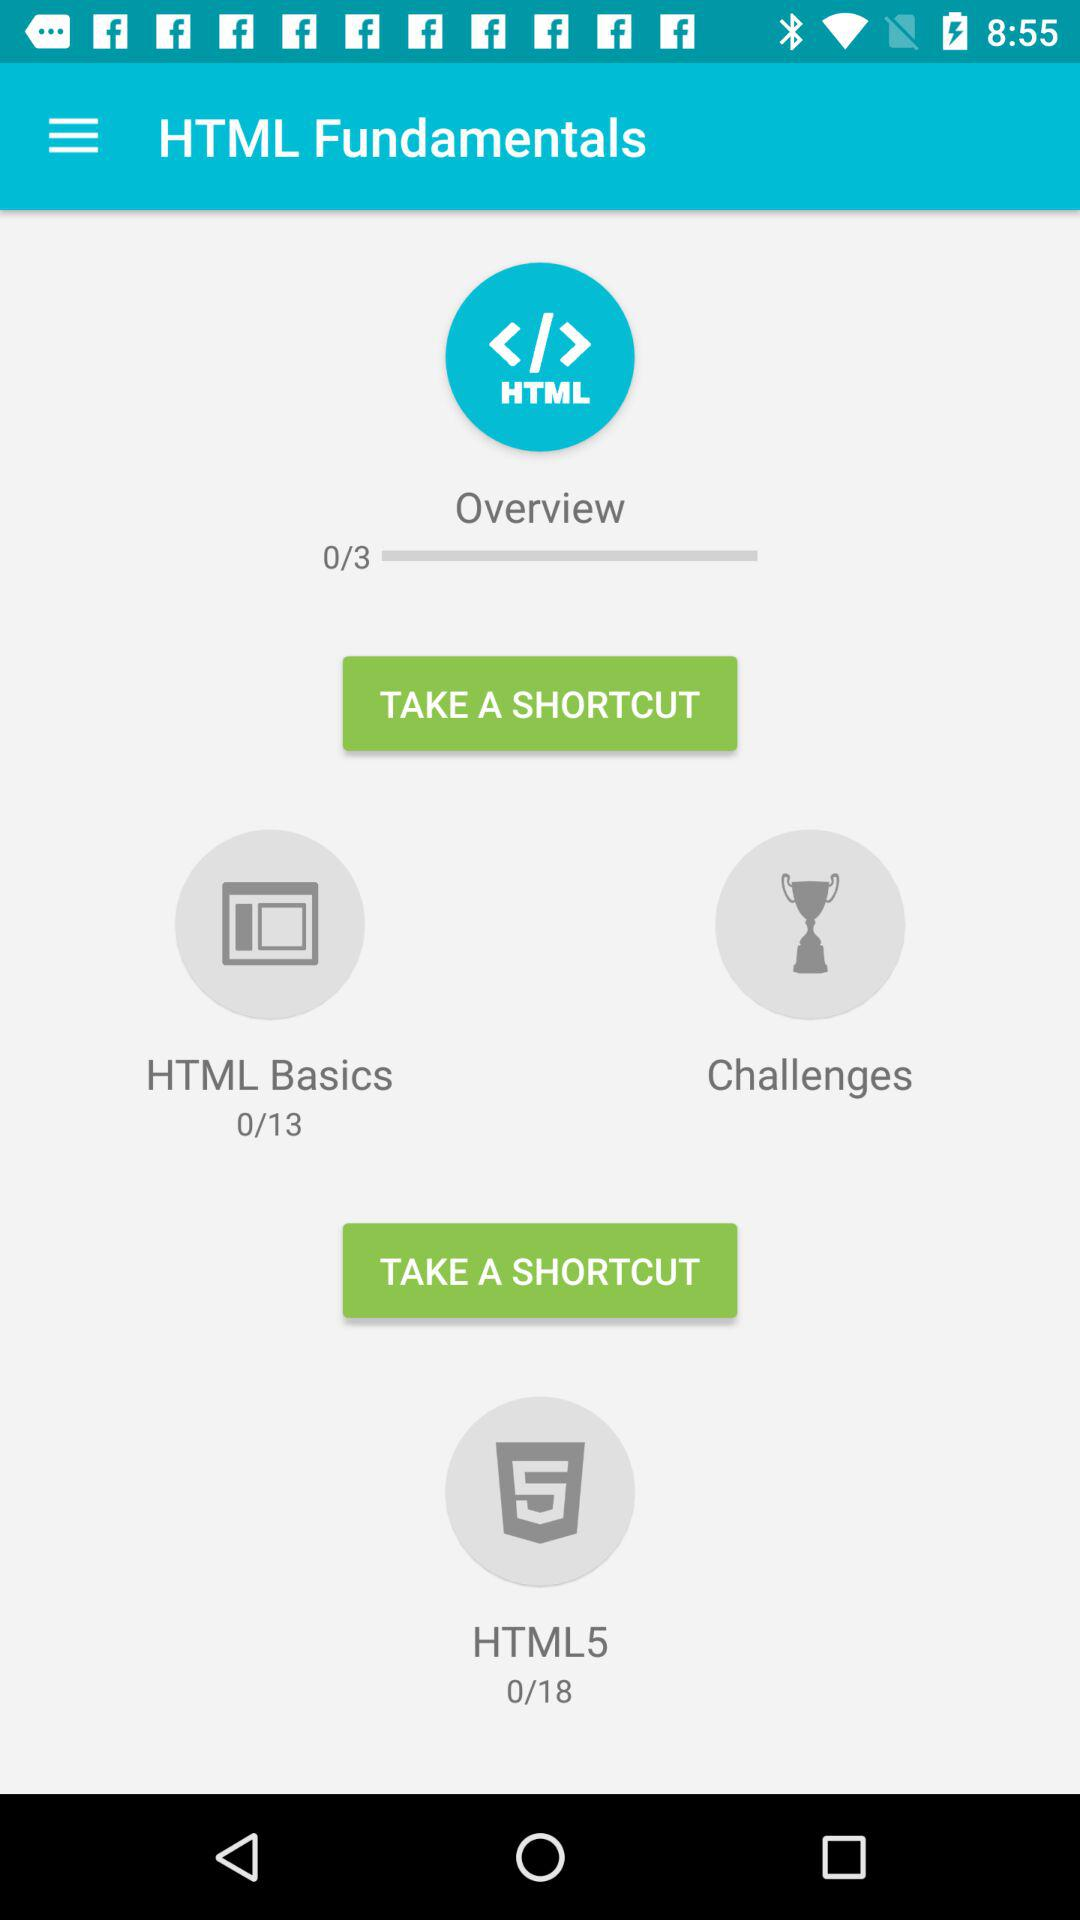How many lectures are in "HTML5"? There are 18 lectures in "HTML5". 